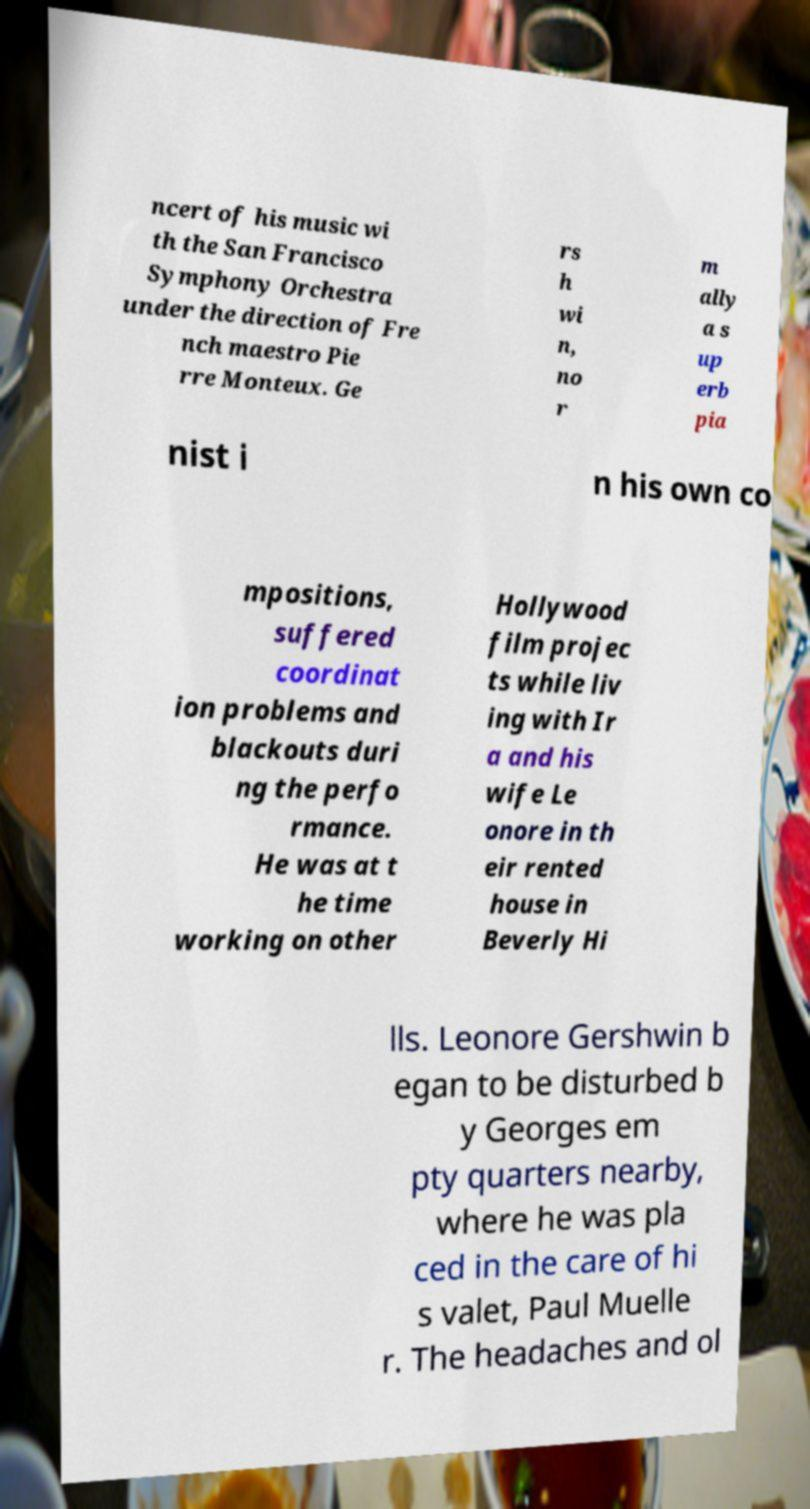Please read and relay the text visible in this image. What does it say? ncert of his music wi th the San Francisco Symphony Orchestra under the direction of Fre nch maestro Pie rre Monteux. Ge rs h wi n, no r m ally a s up erb pia nist i n his own co mpositions, suffered coordinat ion problems and blackouts duri ng the perfo rmance. He was at t he time working on other Hollywood film projec ts while liv ing with Ir a and his wife Le onore in th eir rented house in Beverly Hi lls. Leonore Gershwin b egan to be disturbed b y Georges em pty quarters nearby, where he was pla ced in the care of hi s valet, Paul Muelle r. The headaches and ol 